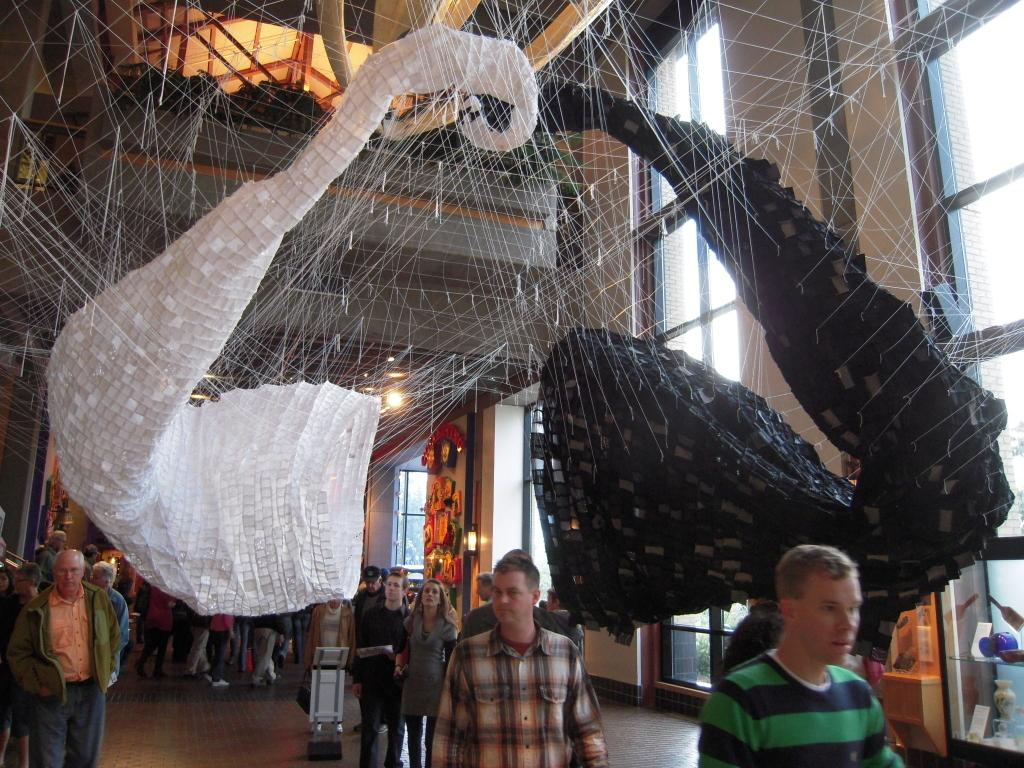What are the people in the image doing? The people in the image are walking. What architectural feature can be seen in the image? There are windows visible in the image. Where is the duck located in the image? There is no duck present in the image. What type of chickens can be seen in the image? There are no chickens present in the image. What type of facility is depicted in the image? The image does not depict a jail or any other specific facility. 